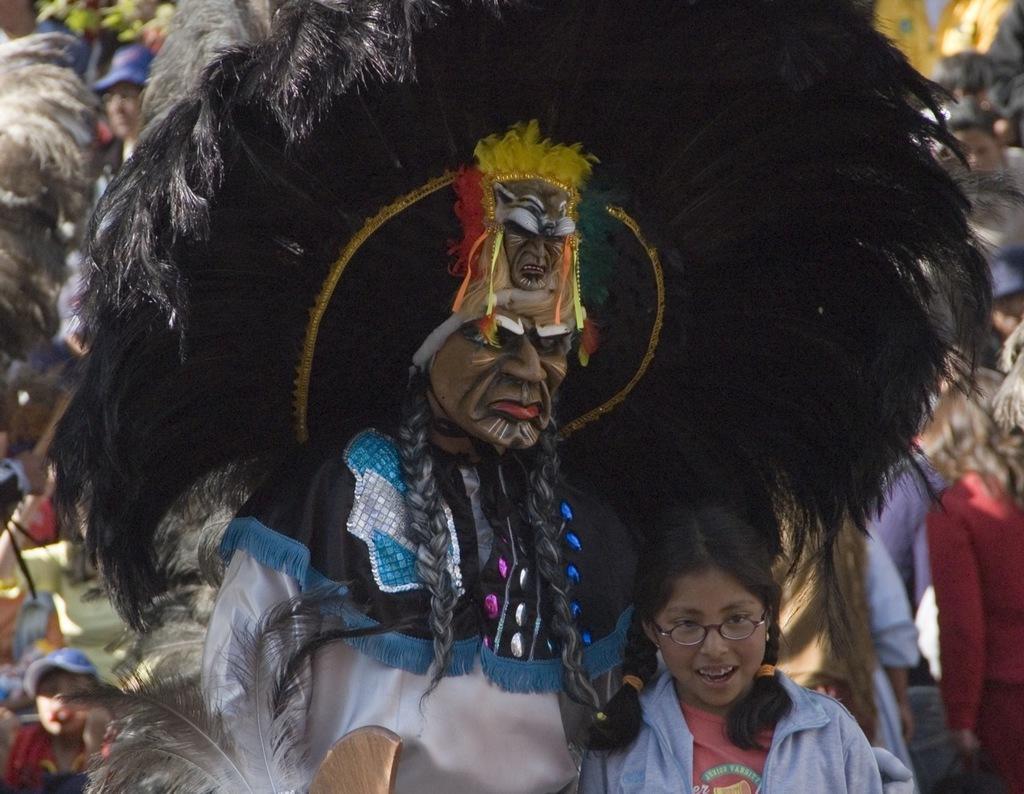Please provide a concise description of this image. In this picture there is a man who is wearing white dress. Beside him there is a girl who is wearing spectacle, jacket and t-shirt. In the background I can see many people were standing. In the top left corner I can see the tree. 